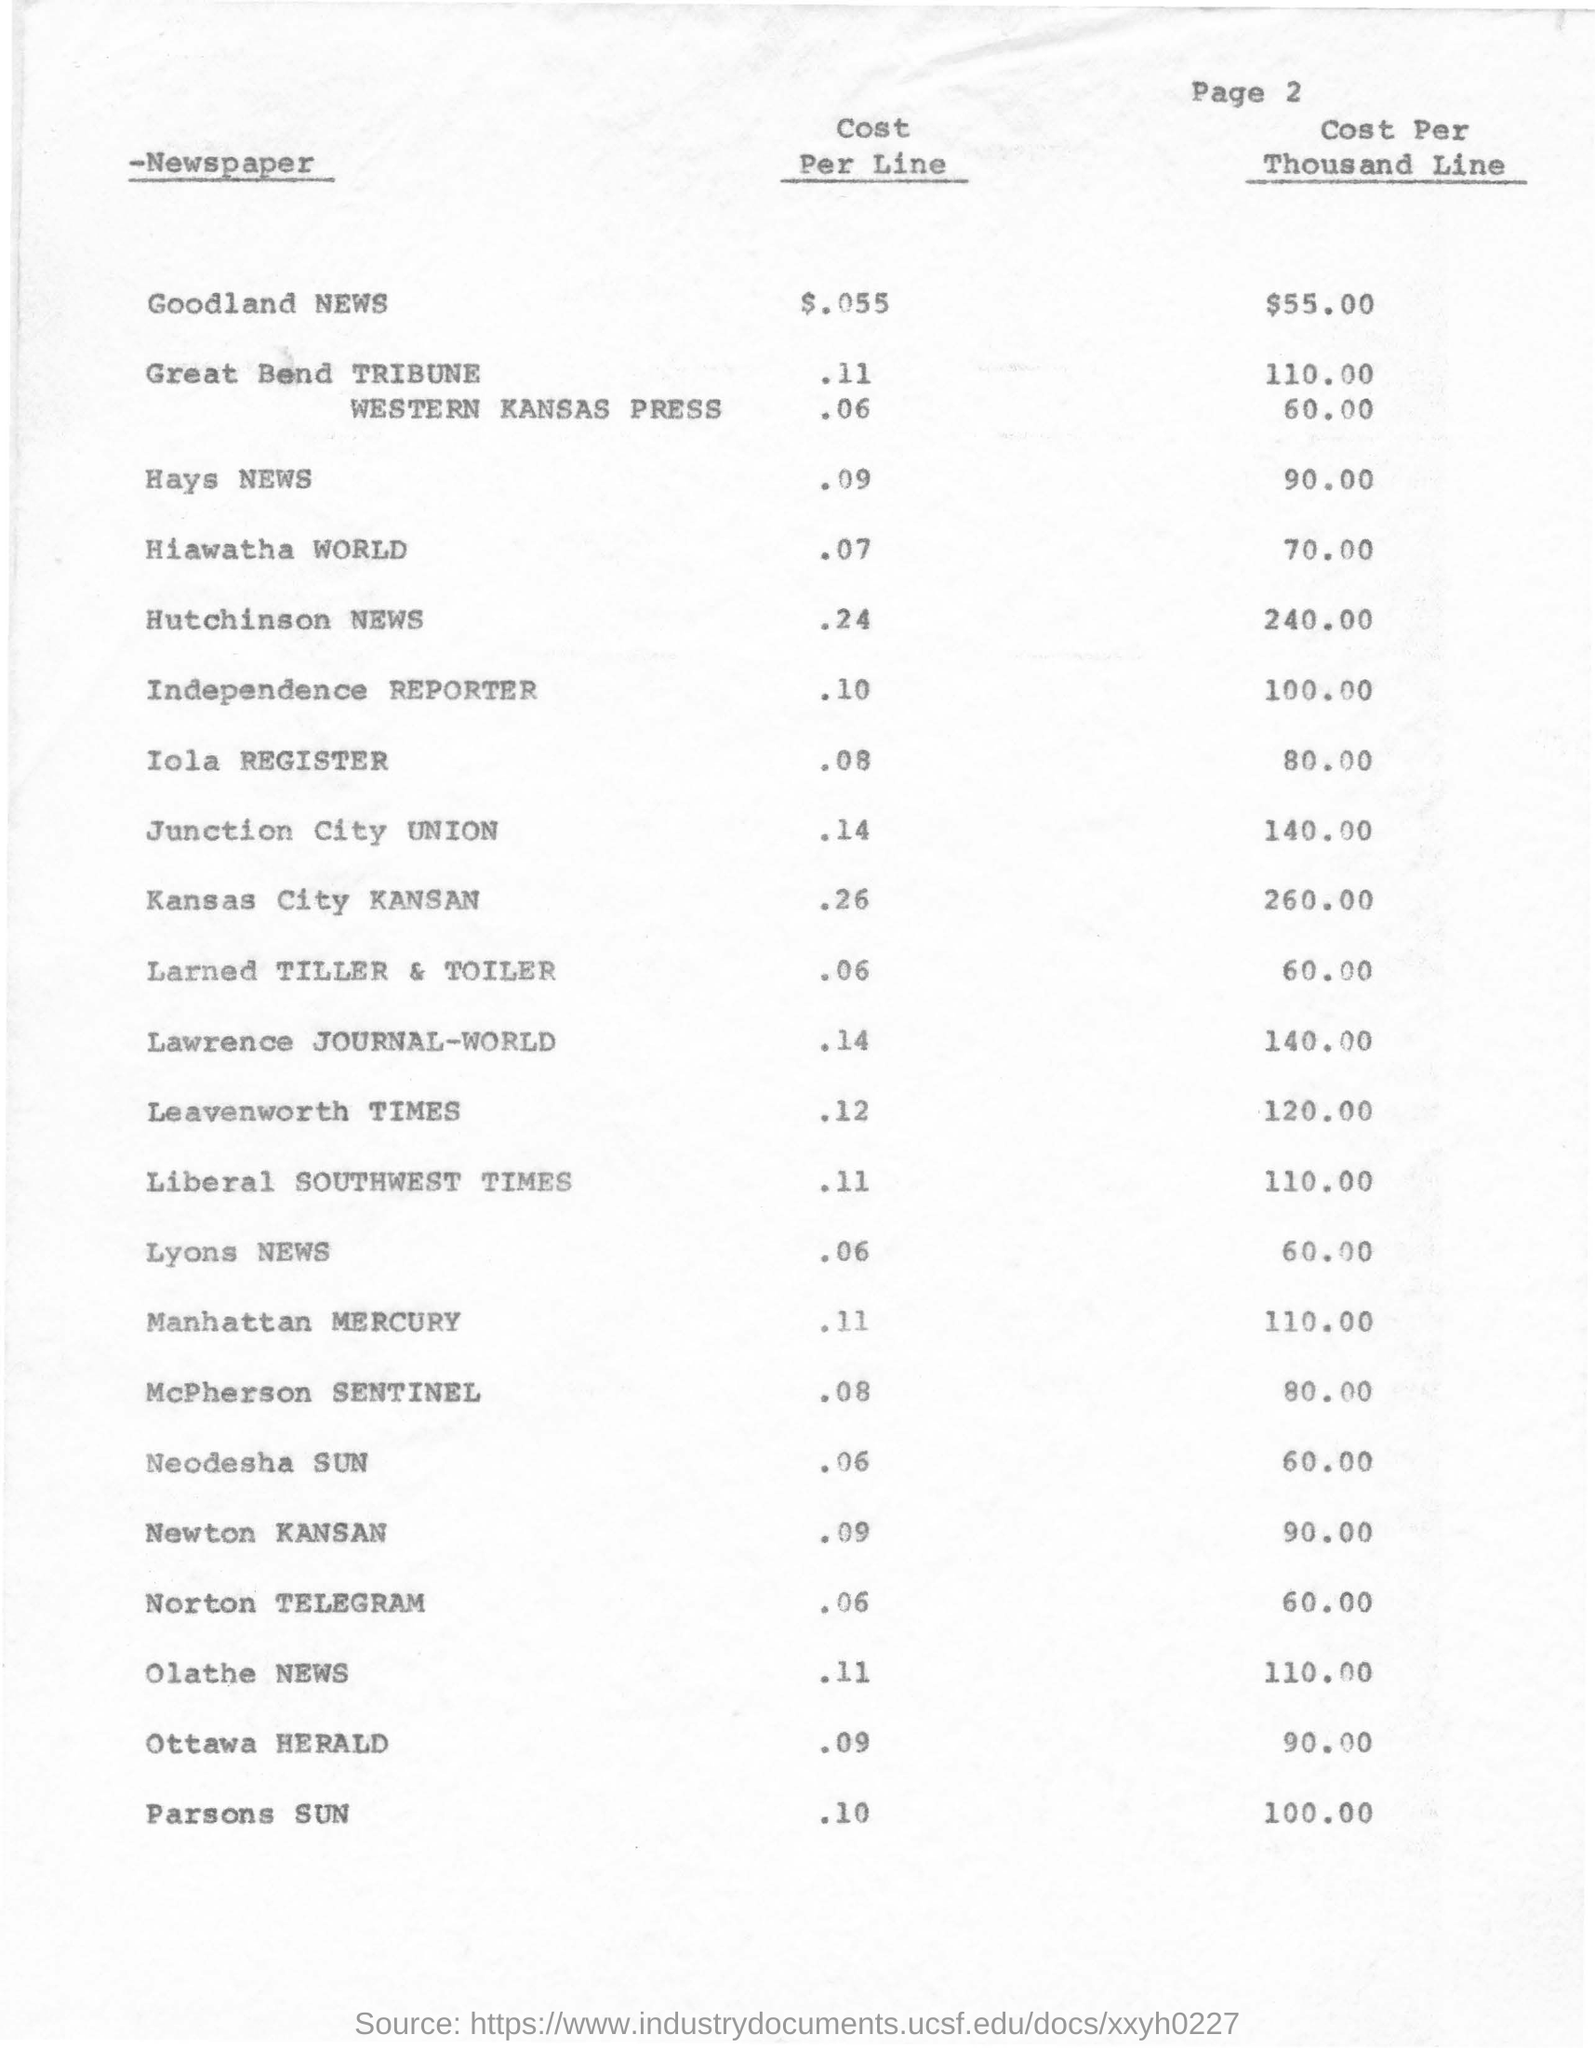Draw attention to some important aspects in this diagram. The page number mentioned in this document is 2. The cost per line for Lyons NEWS is 0.06. The newspaper with a Cost per Thousand Line (CPM) of $240.00 is the Hutchinson NEWS. The cost per thousand lines for Hays NEWS is 90.00. The cost per line for Goodland NEWS is approximately $.055. 